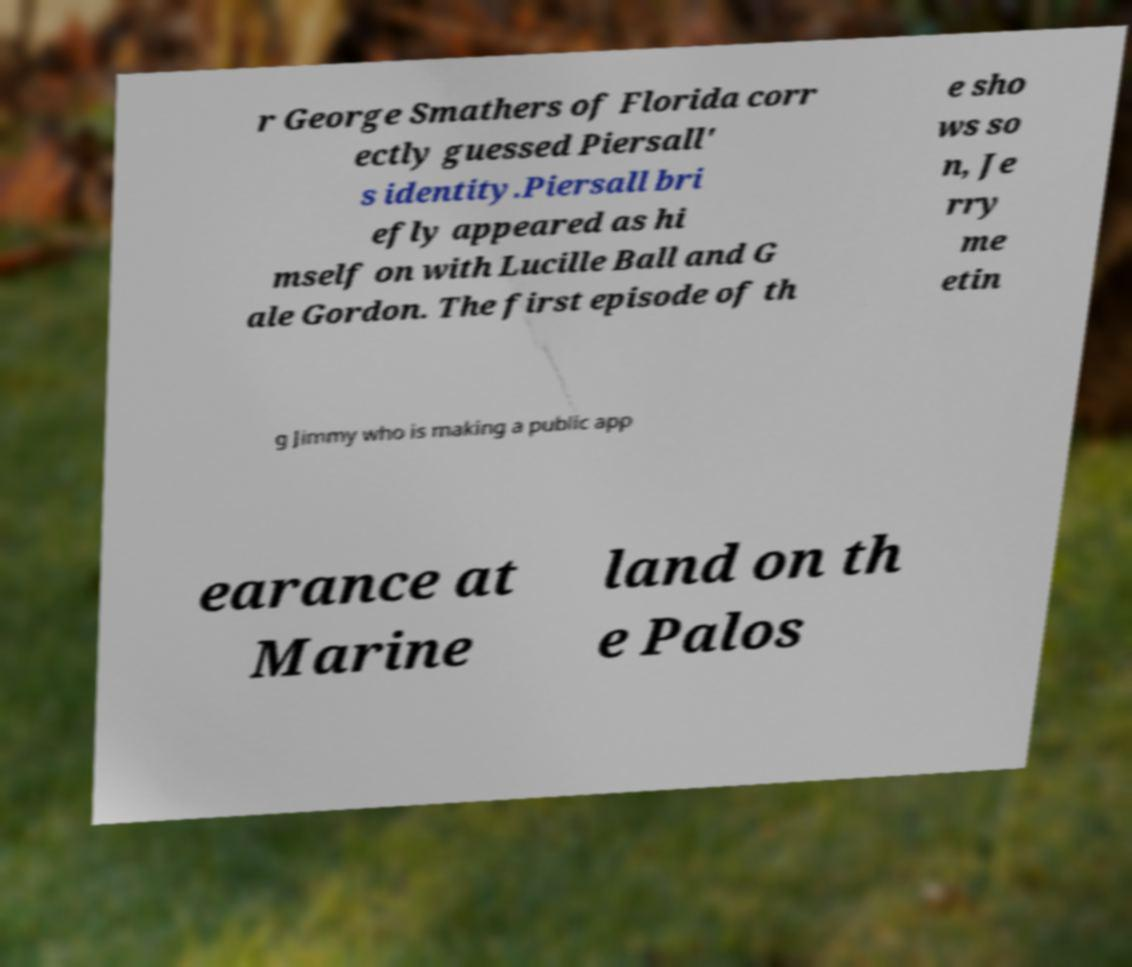For documentation purposes, I need the text within this image transcribed. Could you provide that? r George Smathers of Florida corr ectly guessed Piersall' s identity.Piersall bri efly appeared as hi mself on with Lucille Ball and G ale Gordon. The first episode of th e sho ws so n, Je rry me etin g Jimmy who is making a public app earance at Marine land on th e Palos 